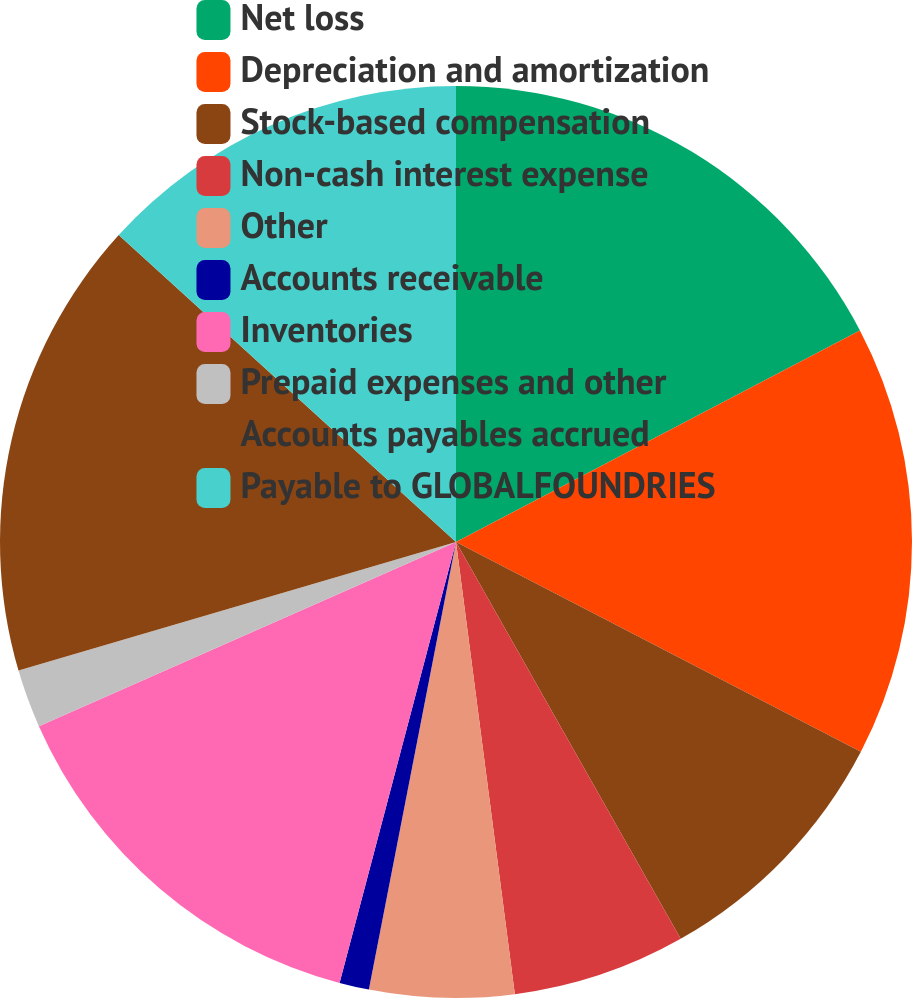<chart> <loc_0><loc_0><loc_500><loc_500><pie_chart><fcel>Net loss<fcel>Depreciation and amortization<fcel>Stock-based compensation<fcel>Non-cash interest expense<fcel>Other<fcel>Accounts receivable<fcel>Inventories<fcel>Prepaid expenses and other<fcel>Accounts payables accrued<fcel>Payable to GLOBALFOUNDRIES<nl><fcel>17.32%<fcel>15.29%<fcel>9.19%<fcel>6.14%<fcel>5.12%<fcel>1.05%<fcel>14.27%<fcel>2.07%<fcel>16.3%<fcel>13.25%<nl></chart> 